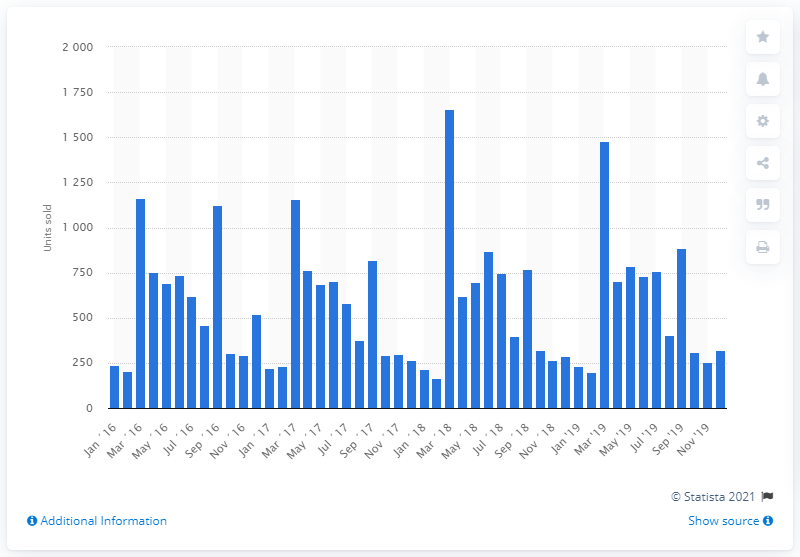Highlight a few significant elements in this photo. In December 2019, Kawasaki sold 323 motorcycles in the UK. 